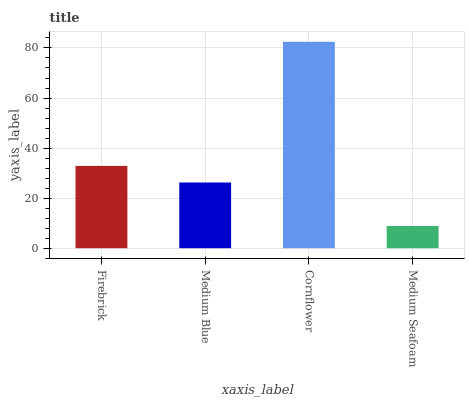Is Medium Blue the minimum?
Answer yes or no. No. Is Medium Blue the maximum?
Answer yes or no. No. Is Firebrick greater than Medium Blue?
Answer yes or no. Yes. Is Medium Blue less than Firebrick?
Answer yes or no. Yes. Is Medium Blue greater than Firebrick?
Answer yes or no. No. Is Firebrick less than Medium Blue?
Answer yes or no. No. Is Firebrick the high median?
Answer yes or no. Yes. Is Medium Blue the low median?
Answer yes or no. Yes. Is Medium Seafoam the high median?
Answer yes or no. No. Is Cornflower the low median?
Answer yes or no. No. 